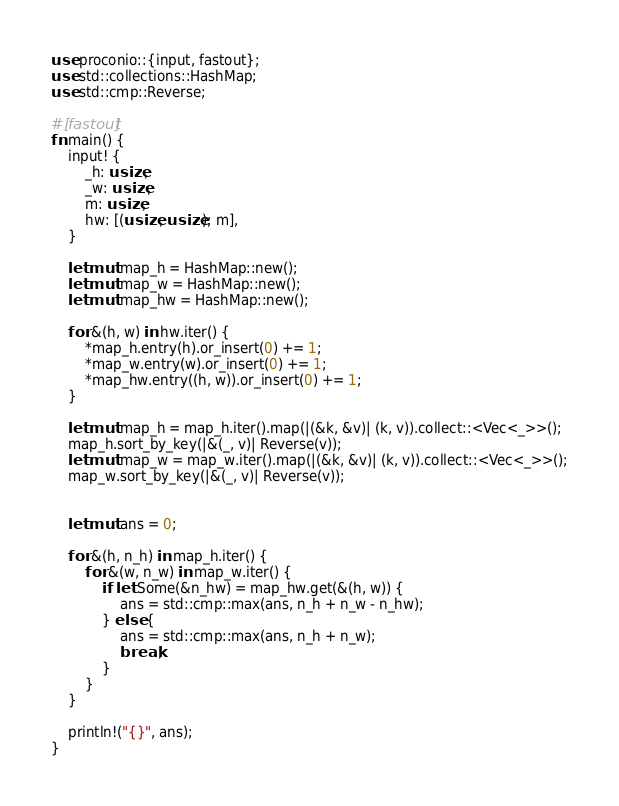<code> <loc_0><loc_0><loc_500><loc_500><_Rust_>use proconio::{input, fastout};
use std::collections::HashMap;
use std::cmp::Reverse;

#[fastout]
fn main() {
    input! {
        _h: usize,
        _w: usize,
        m: usize,
        hw: [(usize, usize); m],
    }

    let mut map_h = HashMap::new();
    let mut map_w = HashMap::new();
    let mut map_hw = HashMap::new();

    for &(h, w) in hw.iter() {
        *map_h.entry(h).or_insert(0) += 1;
        *map_w.entry(w).or_insert(0) += 1;
        *map_hw.entry((h, w)).or_insert(0) += 1;
    }

    let mut map_h = map_h.iter().map(|(&k, &v)| (k, v)).collect::<Vec<_>>();
    map_h.sort_by_key(|&(_, v)| Reverse(v));
    let mut map_w = map_w.iter().map(|(&k, &v)| (k, v)).collect::<Vec<_>>();
    map_w.sort_by_key(|&(_, v)| Reverse(v));


    let mut ans = 0;

    for &(h, n_h) in map_h.iter() {
        for &(w, n_w) in map_w.iter() {
            if let Some(&n_hw) = map_hw.get(&(h, w)) {
                ans = std::cmp::max(ans, n_h + n_w - n_hw);
            } else {
                ans = std::cmp::max(ans, n_h + n_w);
                break;
            }
        }
    }

    println!("{}", ans);
}
</code> 